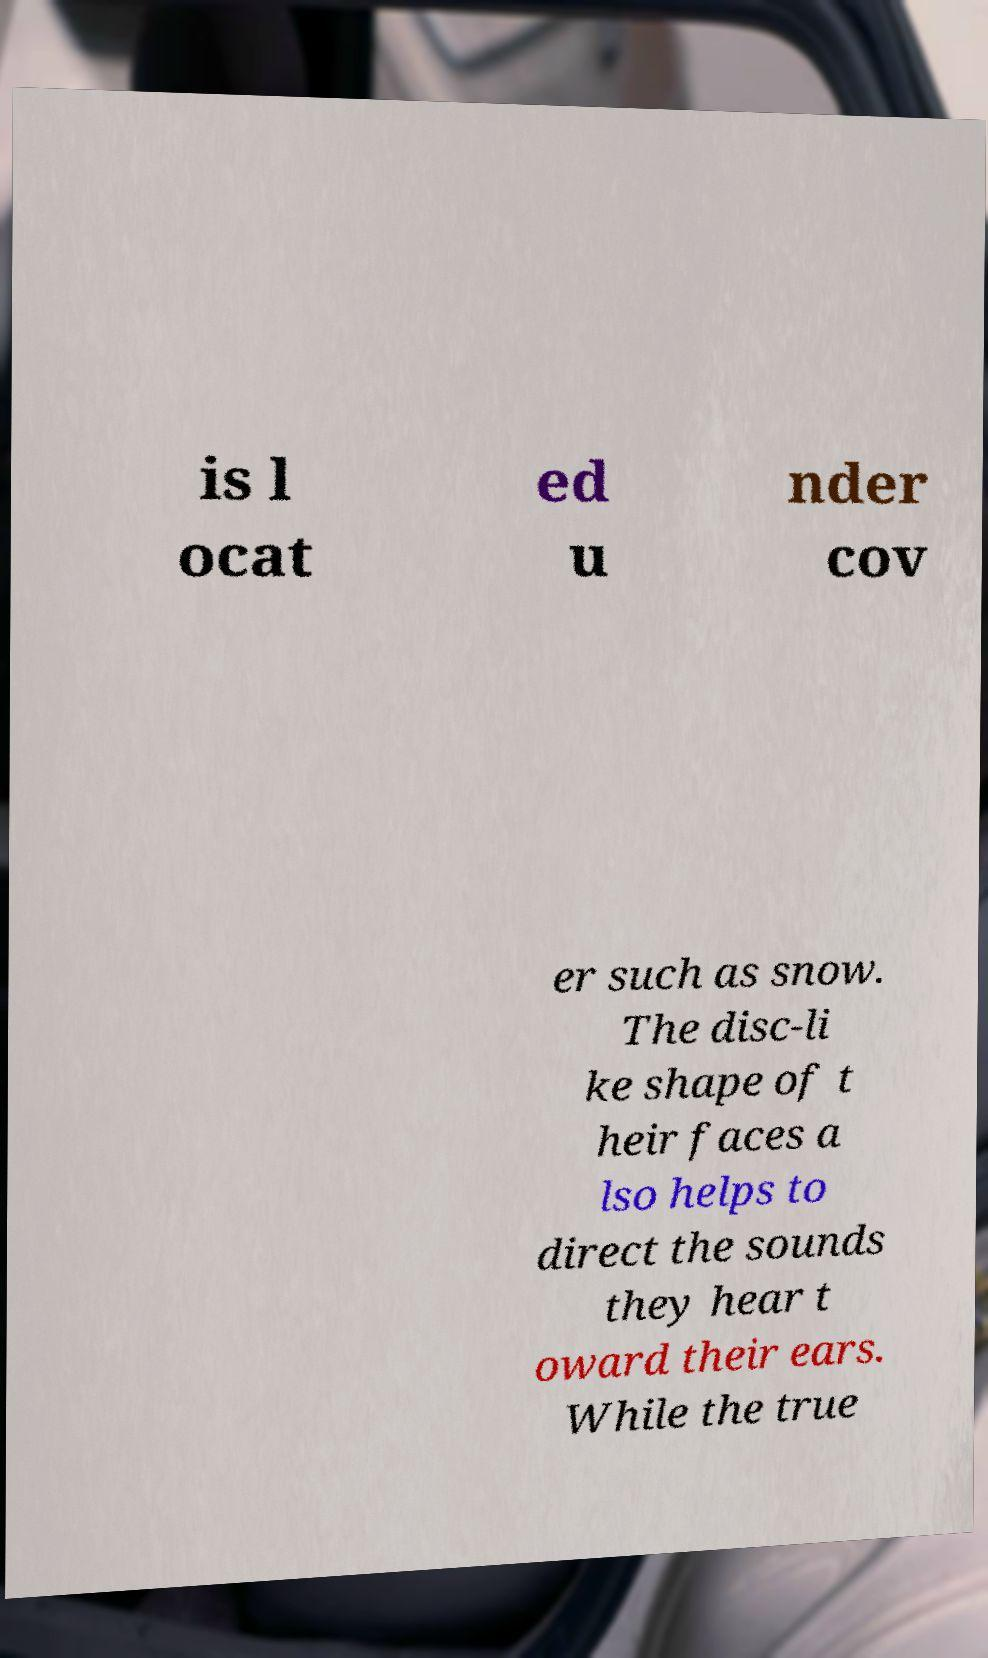I need the written content from this picture converted into text. Can you do that? is l ocat ed u nder cov er such as snow. The disc-li ke shape of t heir faces a lso helps to direct the sounds they hear t oward their ears. While the true 